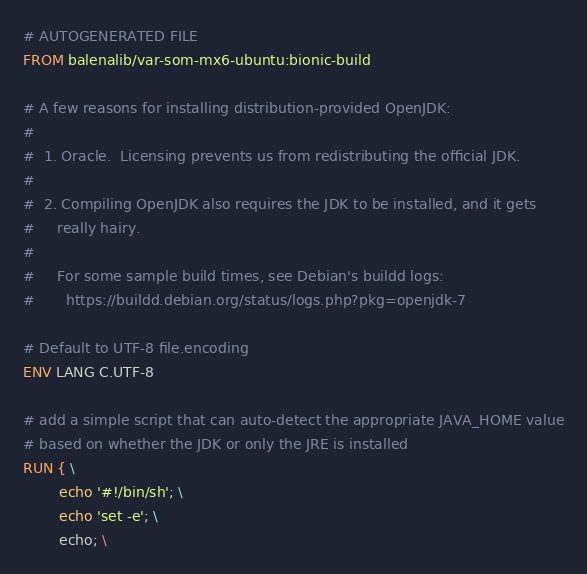<code> <loc_0><loc_0><loc_500><loc_500><_Dockerfile_># AUTOGENERATED FILE
FROM balenalib/var-som-mx6-ubuntu:bionic-build

# A few reasons for installing distribution-provided OpenJDK:
#
#  1. Oracle.  Licensing prevents us from redistributing the official JDK.
#
#  2. Compiling OpenJDK also requires the JDK to be installed, and it gets
#     really hairy.
#
#     For some sample build times, see Debian's buildd logs:
#       https://buildd.debian.org/status/logs.php?pkg=openjdk-7

# Default to UTF-8 file.encoding
ENV LANG C.UTF-8

# add a simple script that can auto-detect the appropriate JAVA_HOME value
# based on whether the JDK or only the JRE is installed
RUN { \
		echo '#!/bin/sh'; \
		echo 'set -e'; \
		echo; \</code> 